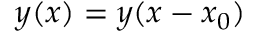Convert formula to latex. <formula><loc_0><loc_0><loc_500><loc_500>y ( x ) = y ( x - x _ { 0 } )</formula> 